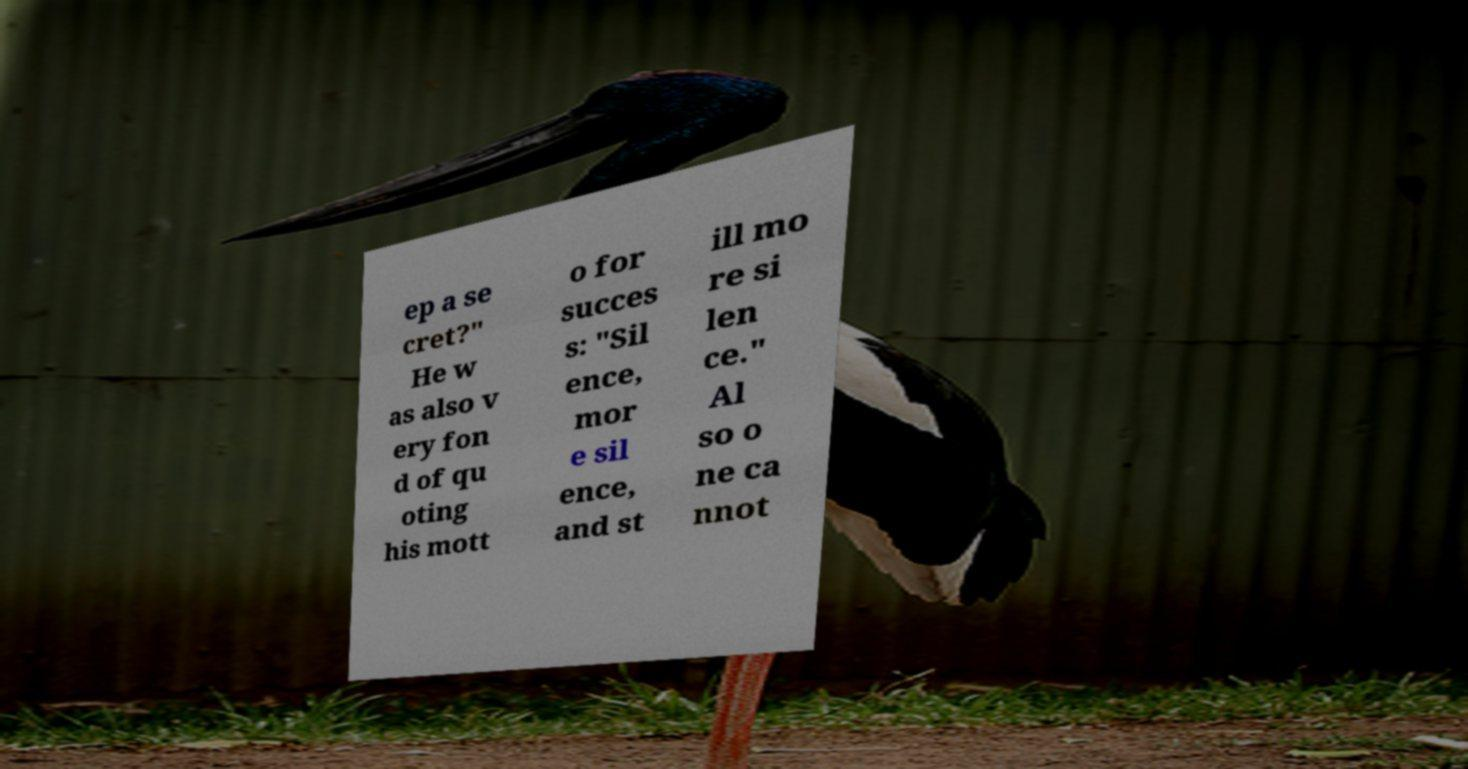For documentation purposes, I need the text within this image transcribed. Could you provide that? ep a se cret?" He w as also v ery fon d of qu oting his mott o for succes s: "Sil ence, mor e sil ence, and st ill mo re si len ce." Al so o ne ca nnot 